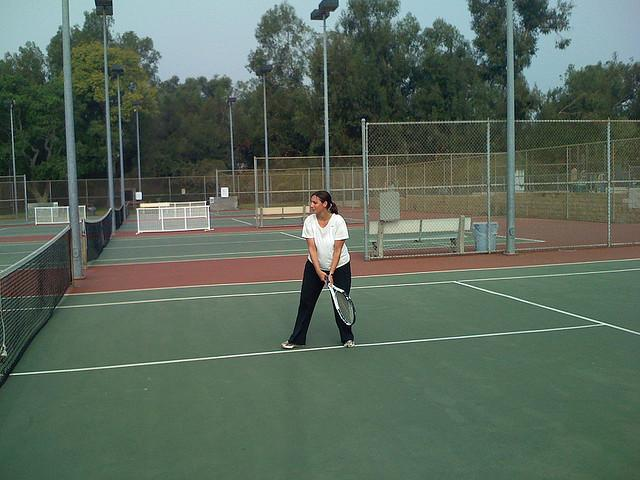What are the tall silver poles used for? Please explain your reasoning. lighting. There are light fixtures at the top of them 